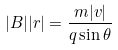Convert formula to latex. <formula><loc_0><loc_0><loc_500><loc_500>| B | | r | = \frac { m | v | } { q \sin \theta }</formula> 